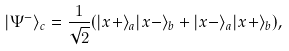Convert formula to latex. <formula><loc_0><loc_0><loc_500><loc_500>| \Psi ^ { - } \rangle _ { c } = \frac { 1 } { \sqrt { 2 } } ( | x + \rangle _ { a } | x - \rangle _ { b } + | x - \rangle _ { a } | x + \rangle _ { b } ) ,</formula> 